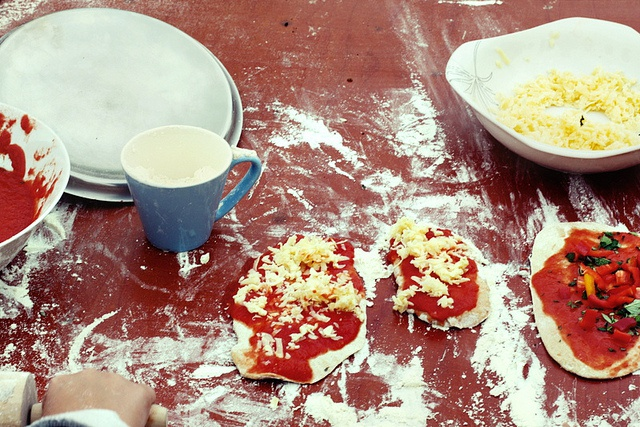Describe the objects in this image and their specific colors. I can see dining table in beige, brown, and maroon tones, bowl in maroon, beige, khaki, and brown tones, pizza in maroon, brown, lightyellow, khaki, and tan tones, pizza in maroon, brown, beige, and red tones, and cup in maroon, beige, gray, blue, and navy tones in this image. 